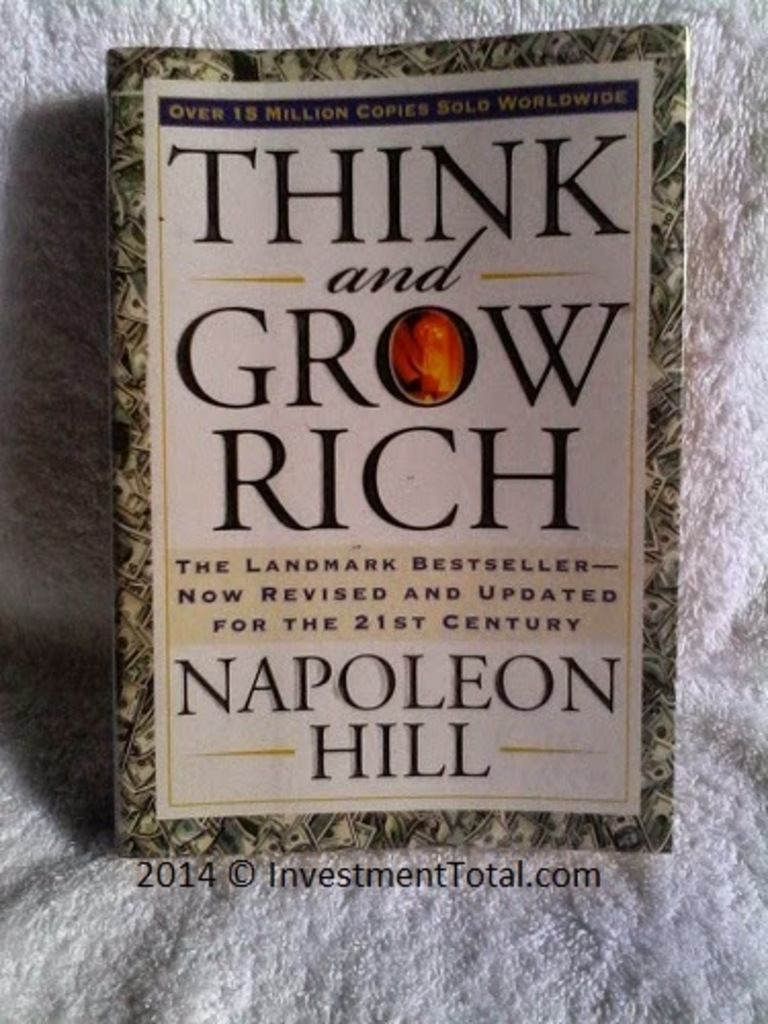What are the themes explored in 'Think and Grow Rich' and how might the cover design reflect these themes? The book delves into themes of personal success, wealth creation, and the psychological strategies of becoming prosperous. The cover design, with its lavish use of gold, symbolizes wealth and achievement. The emblem prominently featuring the word 'Rich' serves as a bold reminder of the book's primary focus. The overall aesthetics may be viewed as conveying a sense of opportunity and the lucrative rewards of diligently applying Hill's principles. Can you tell me more about Napoleon Hill and his influence in writing this book? Napoleon Hill was an American self-help author, one of the earliest producers of the personal-success genre. He wrote 'Think and Grow Rich' in 1937, inspired by a suggestion from businessman Andrew Carnegie. This book distills stories and insights from the lives of Carnegie, Thomas Edison, and other millionaires of his time, providing readers with steps to achieve their own success. Hill's influence stems from his knack for distilling complex concepts into compelling, actionable advice that has inspired many entrepreneurs worldwide. 